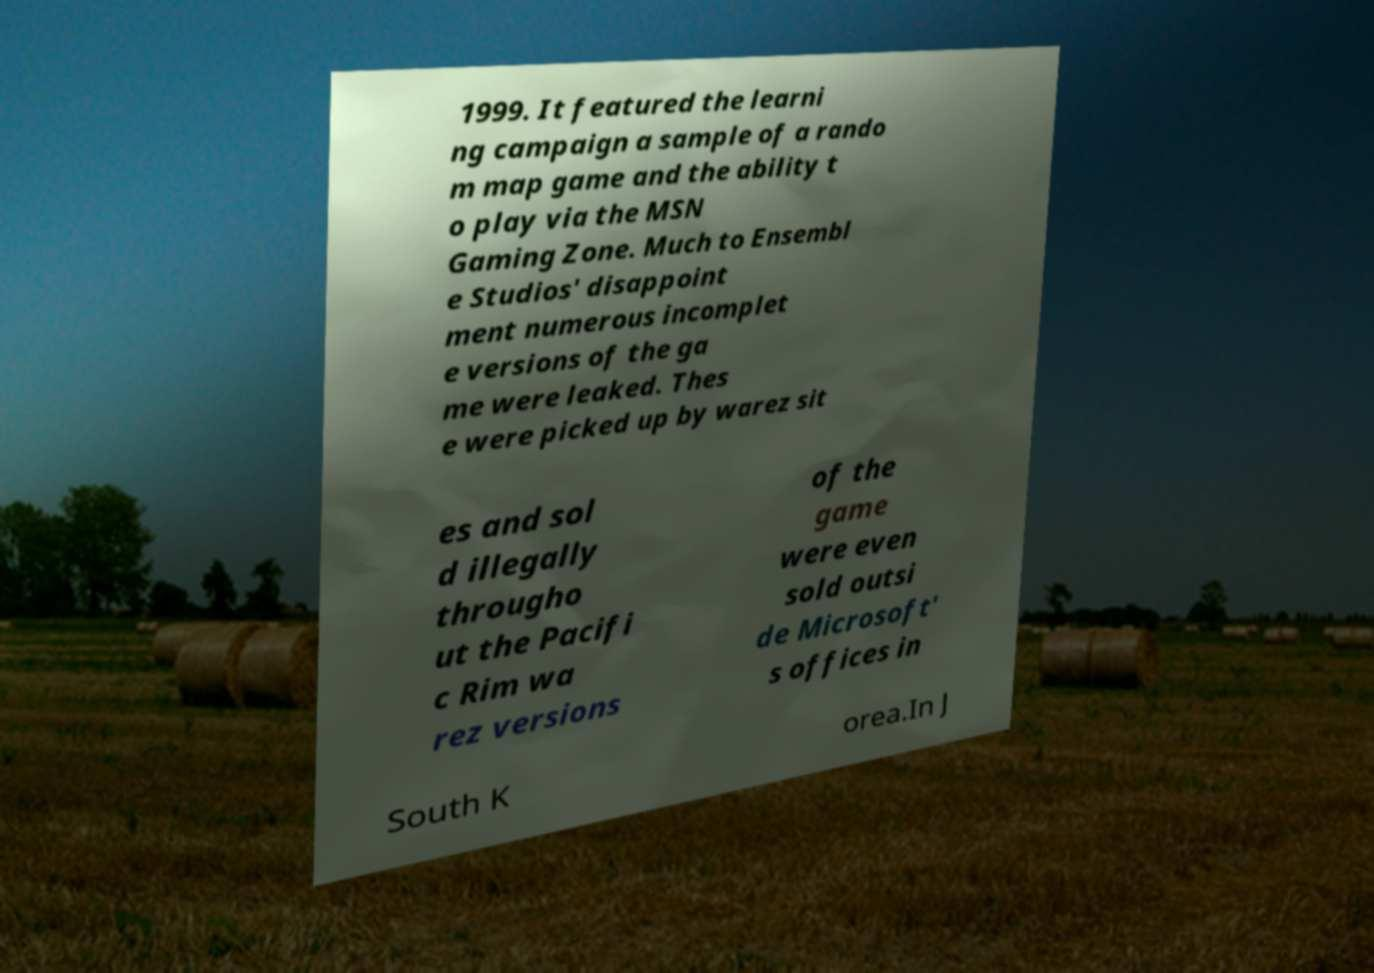Could you extract and type out the text from this image? 1999. It featured the learni ng campaign a sample of a rando m map game and the ability t o play via the MSN Gaming Zone. Much to Ensembl e Studios' disappoint ment numerous incomplet e versions of the ga me were leaked. Thes e were picked up by warez sit es and sol d illegally througho ut the Pacifi c Rim wa rez versions of the game were even sold outsi de Microsoft' s offices in South K orea.In J 